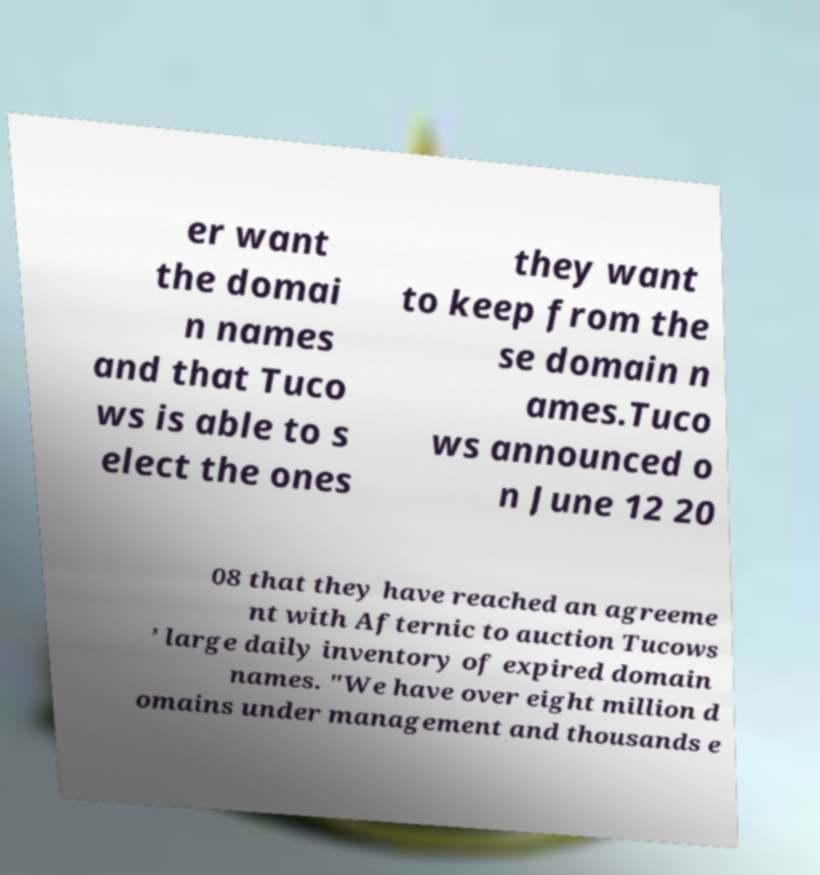Please identify and transcribe the text found in this image. er want the domai n names and that Tuco ws is able to s elect the ones they want to keep from the se domain n ames.Tuco ws announced o n June 12 20 08 that they have reached an agreeme nt with Afternic to auction Tucows ’ large daily inventory of expired domain names. "We have over eight million d omains under management and thousands e 